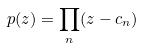Convert formula to latex. <formula><loc_0><loc_0><loc_500><loc_500>p ( z ) = \prod _ { n } ( z - c _ { n } )</formula> 